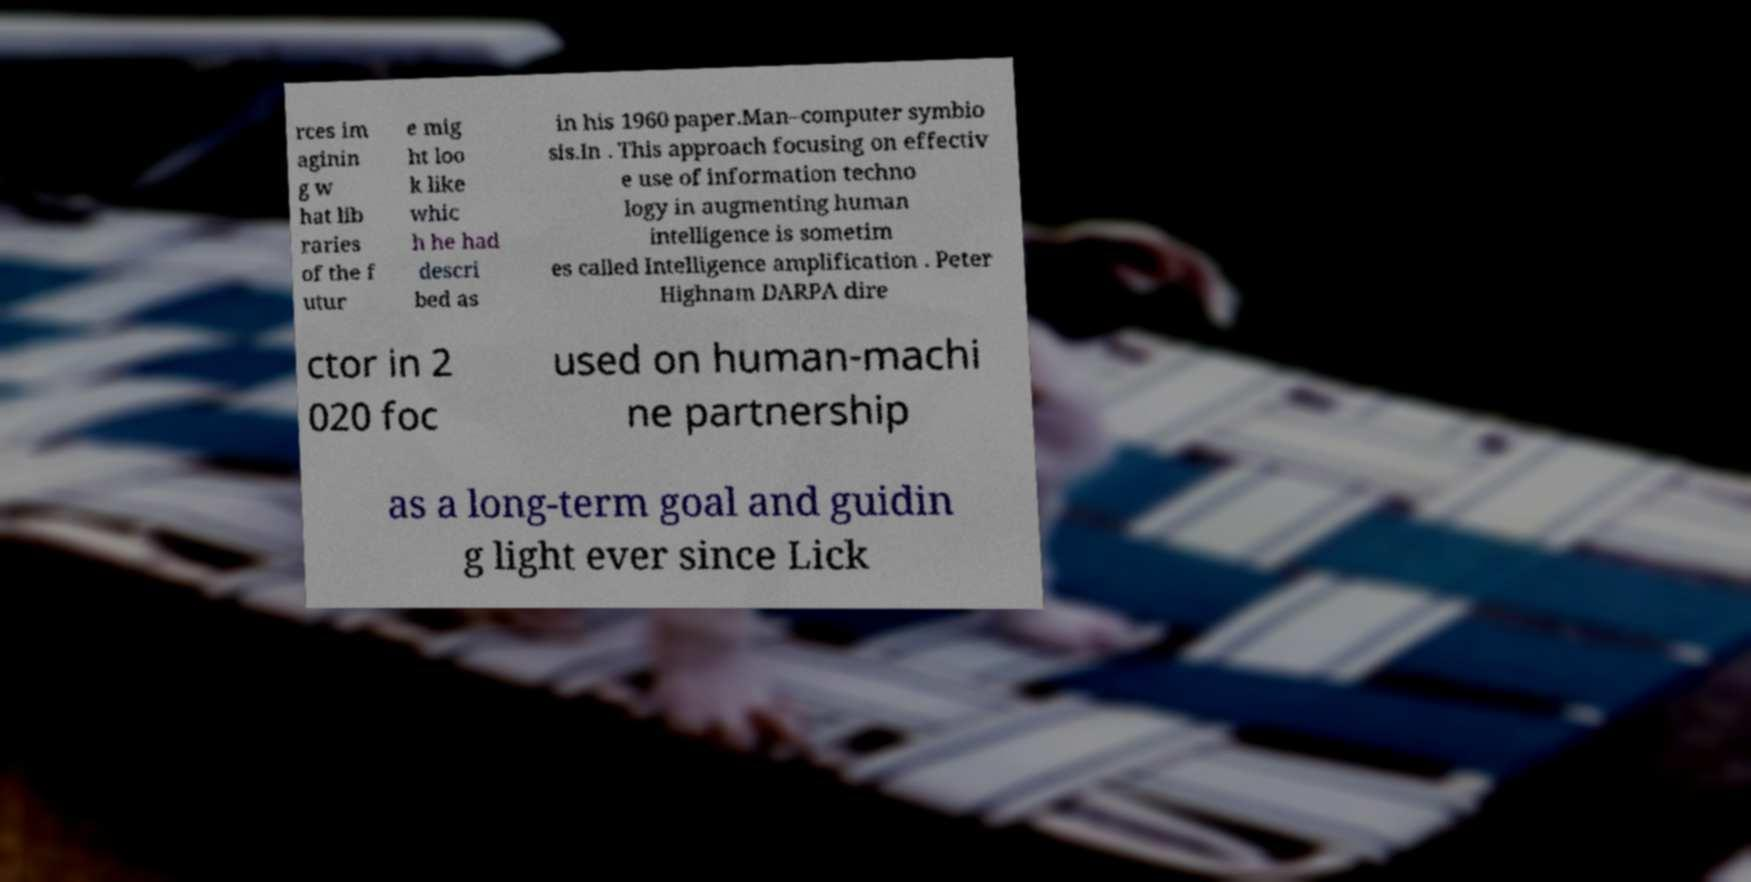Can you accurately transcribe the text from the provided image for me? rces im aginin g w hat lib raries of the f utur e mig ht loo k like whic h he had descri bed as in his 1960 paper.Man–computer symbio sis.In . This approach focusing on effectiv e use of information techno logy in augmenting human intelligence is sometim es called Intelligence amplification . Peter Highnam DARPA dire ctor in 2 020 foc used on human-machi ne partnership as a long-term goal and guidin g light ever since Lick 